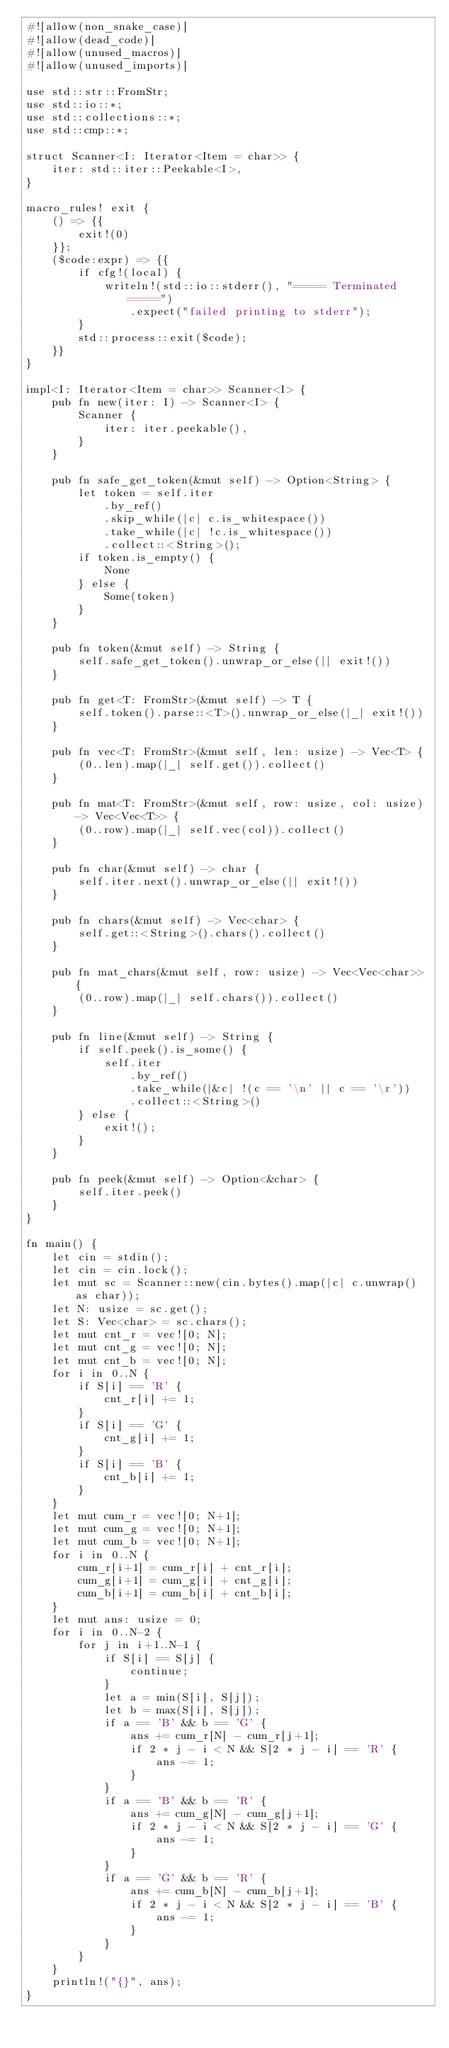<code> <loc_0><loc_0><loc_500><loc_500><_Rust_>#![allow(non_snake_case)]
#![allow(dead_code)]
#![allow(unused_macros)]
#![allow(unused_imports)]

use std::str::FromStr;
use std::io::*;
use std::collections::*;
use std::cmp::*;

struct Scanner<I: Iterator<Item = char>> {
    iter: std::iter::Peekable<I>,
}

macro_rules! exit {
    () => {{
        exit!(0)
    }};
    ($code:expr) => {{
        if cfg!(local) {
            writeln!(std::io::stderr(), "===== Terminated =====")
                .expect("failed printing to stderr");
        }
        std::process::exit($code);
    }}
}

impl<I: Iterator<Item = char>> Scanner<I> {
    pub fn new(iter: I) -> Scanner<I> {
        Scanner {
            iter: iter.peekable(),
        }
    }

    pub fn safe_get_token(&mut self) -> Option<String> {
        let token = self.iter
            .by_ref()
            .skip_while(|c| c.is_whitespace())
            .take_while(|c| !c.is_whitespace())
            .collect::<String>();
        if token.is_empty() {
            None
        } else {
            Some(token)
        }
    }

    pub fn token(&mut self) -> String {
        self.safe_get_token().unwrap_or_else(|| exit!())
    }

    pub fn get<T: FromStr>(&mut self) -> T {
        self.token().parse::<T>().unwrap_or_else(|_| exit!())
    }

    pub fn vec<T: FromStr>(&mut self, len: usize) -> Vec<T> {
        (0..len).map(|_| self.get()).collect()
    }

    pub fn mat<T: FromStr>(&mut self, row: usize, col: usize) -> Vec<Vec<T>> {
        (0..row).map(|_| self.vec(col)).collect()
    }

    pub fn char(&mut self) -> char {
        self.iter.next().unwrap_or_else(|| exit!())
    }

    pub fn chars(&mut self) -> Vec<char> {
        self.get::<String>().chars().collect()
    }

    pub fn mat_chars(&mut self, row: usize) -> Vec<Vec<char>> {
        (0..row).map(|_| self.chars()).collect()
    }

    pub fn line(&mut self) -> String {
        if self.peek().is_some() {
            self.iter
                .by_ref()
                .take_while(|&c| !(c == '\n' || c == '\r'))
                .collect::<String>()
        } else {
            exit!();
        }
    }

    pub fn peek(&mut self) -> Option<&char> {
        self.iter.peek()
    }
}

fn main() {
    let cin = stdin();
    let cin = cin.lock();
    let mut sc = Scanner::new(cin.bytes().map(|c| c.unwrap() as char));
    let N: usize = sc.get();
    let S: Vec<char> = sc.chars();
    let mut cnt_r = vec![0; N];
    let mut cnt_g = vec![0; N];
    let mut cnt_b = vec![0; N];
    for i in 0..N {
        if S[i] == 'R' {
            cnt_r[i] += 1;
        }
        if S[i] == 'G' {
            cnt_g[i] += 1;
        }
        if S[i] == 'B' {
            cnt_b[i] += 1;
        }
    }
    let mut cum_r = vec![0; N+1];
    let mut cum_g = vec![0; N+1];
    let mut cum_b = vec![0; N+1];
    for i in 0..N {
        cum_r[i+1] = cum_r[i] + cnt_r[i];
        cum_g[i+1] = cum_g[i] + cnt_g[i];
        cum_b[i+1] = cum_b[i] + cnt_b[i];
    }
    let mut ans: usize = 0;
    for i in 0..N-2 {
        for j in i+1..N-1 {
            if S[i] == S[j] {
                continue;
            }
            let a = min(S[i], S[j]);
            let b = max(S[i], S[j]);
            if a == 'B' && b == 'G' {
                ans += cum_r[N] - cum_r[j+1];
                if 2 * j - i < N && S[2 * j - i] == 'R' {
                    ans -= 1;
                }
            }
            if a == 'B' && b == 'R' {
                ans += cum_g[N] - cum_g[j+1];
                if 2 * j - i < N && S[2 * j - i] == 'G' {
                    ans -= 1;
                }
            }
            if a == 'G' && b == 'R' {
                ans += cum_b[N] - cum_b[j+1];
                if 2 * j - i < N && S[2 * j - i] == 'B' {
                    ans -= 1;
                }
            }
        }
    }
    println!("{}", ans);
}
</code> 